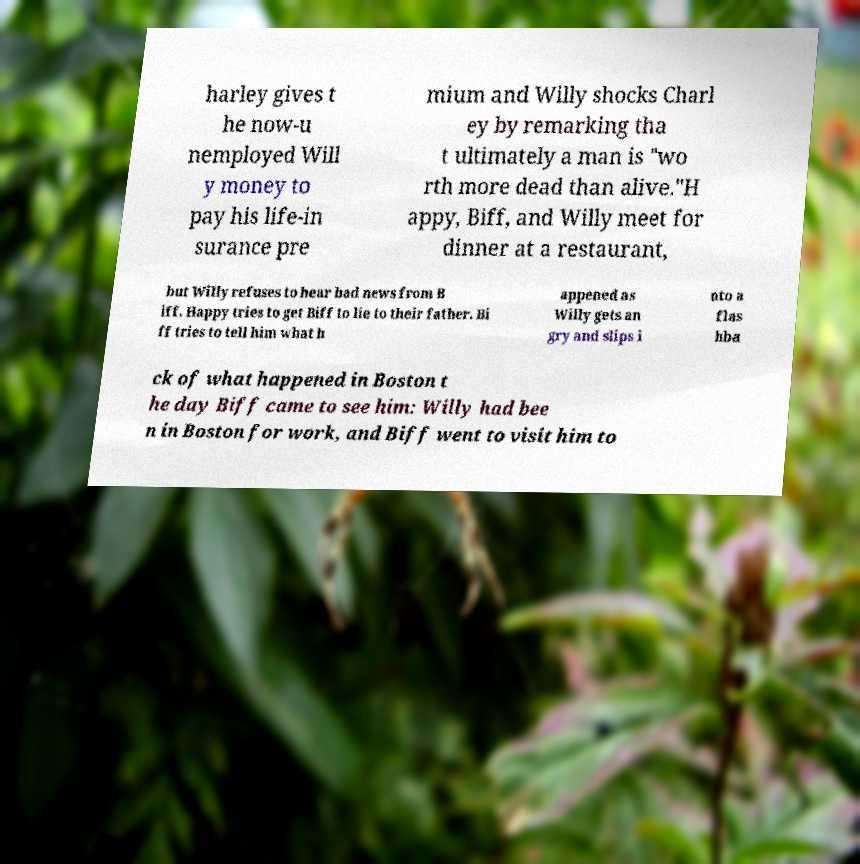Can you accurately transcribe the text from the provided image for me? harley gives t he now-u nemployed Will y money to pay his life-in surance pre mium and Willy shocks Charl ey by remarking tha t ultimately a man is "wo rth more dead than alive."H appy, Biff, and Willy meet for dinner at a restaurant, but Willy refuses to hear bad news from B iff. Happy tries to get Biff to lie to their father. Bi ff tries to tell him what h appened as Willy gets an gry and slips i nto a flas hba ck of what happened in Boston t he day Biff came to see him: Willy had bee n in Boston for work, and Biff went to visit him to 